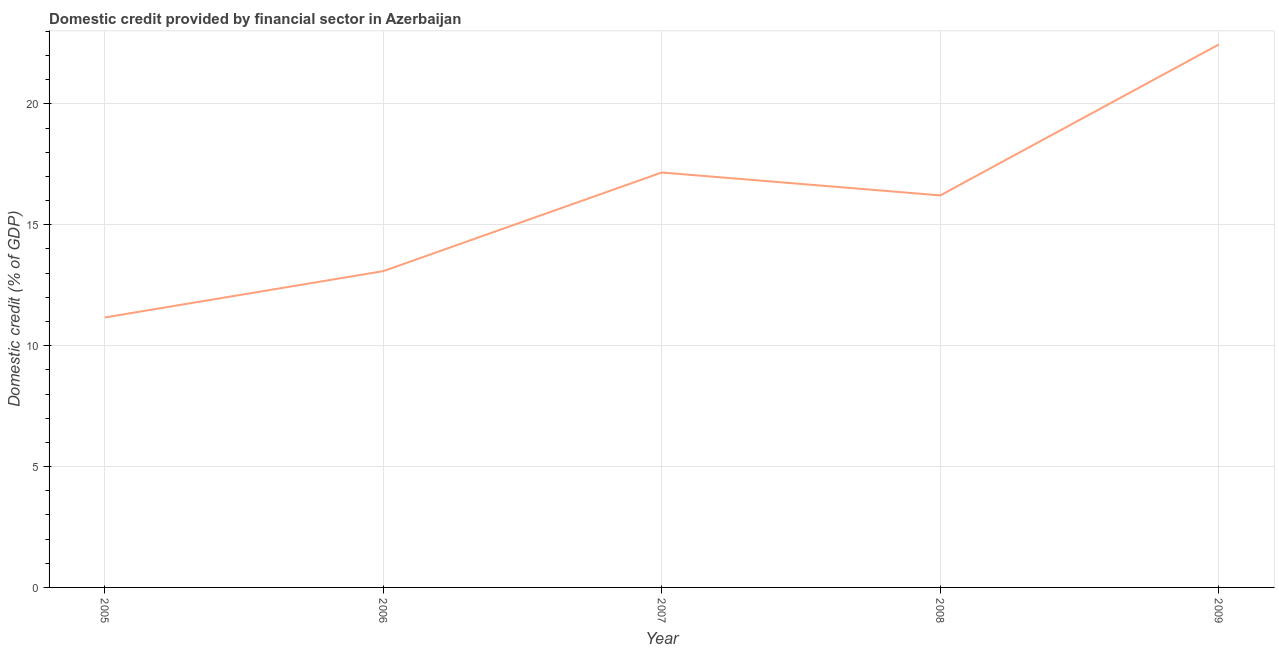What is the domestic credit provided by financial sector in 2007?
Provide a succinct answer. 17.16. Across all years, what is the maximum domestic credit provided by financial sector?
Offer a terse response. 22.46. Across all years, what is the minimum domestic credit provided by financial sector?
Ensure brevity in your answer.  11.17. In which year was the domestic credit provided by financial sector maximum?
Make the answer very short. 2009. In which year was the domestic credit provided by financial sector minimum?
Give a very brief answer. 2005. What is the sum of the domestic credit provided by financial sector?
Offer a very short reply. 80.08. What is the difference between the domestic credit provided by financial sector in 2005 and 2008?
Keep it short and to the point. -5.05. What is the average domestic credit provided by financial sector per year?
Your answer should be very brief. 16.02. What is the median domestic credit provided by financial sector?
Offer a very short reply. 16.22. In how many years, is the domestic credit provided by financial sector greater than 21 %?
Give a very brief answer. 1. Do a majority of the years between 2009 and 2008 (inclusive) have domestic credit provided by financial sector greater than 4 %?
Give a very brief answer. No. What is the ratio of the domestic credit provided by financial sector in 2006 to that in 2008?
Provide a succinct answer. 0.81. Is the domestic credit provided by financial sector in 2005 less than that in 2006?
Offer a terse response. Yes. Is the difference between the domestic credit provided by financial sector in 2005 and 2008 greater than the difference between any two years?
Provide a succinct answer. No. What is the difference between the highest and the second highest domestic credit provided by financial sector?
Ensure brevity in your answer.  5.3. What is the difference between the highest and the lowest domestic credit provided by financial sector?
Make the answer very short. 11.29. In how many years, is the domestic credit provided by financial sector greater than the average domestic credit provided by financial sector taken over all years?
Keep it short and to the point. 3. How many lines are there?
Your response must be concise. 1. Does the graph contain any zero values?
Make the answer very short. No. Does the graph contain grids?
Ensure brevity in your answer.  Yes. What is the title of the graph?
Offer a very short reply. Domestic credit provided by financial sector in Azerbaijan. What is the label or title of the X-axis?
Your answer should be compact. Year. What is the label or title of the Y-axis?
Ensure brevity in your answer.  Domestic credit (% of GDP). What is the Domestic credit (% of GDP) of 2005?
Provide a succinct answer. 11.17. What is the Domestic credit (% of GDP) in 2006?
Offer a very short reply. 13.08. What is the Domestic credit (% of GDP) of 2007?
Offer a very short reply. 17.16. What is the Domestic credit (% of GDP) of 2008?
Provide a short and direct response. 16.22. What is the Domestic credit (% of GDP) of 2009?
Give a very brief answer. 22.46. What is the difference between the Domestic credit (% of GDP) in 2005 and 2006?
Ensure brevity in your answer.  -1.92. What is the difference between the Domestic credit (% of GDP) in 2005 and 2007?
Ensure brevity in your answer.  -6. What is the difference between the Domestic credit (% of GDP) in 2005 and 2008?
Your response must be concise. -5.05. What is the difference between the Domestic credit (% of GDP) in 2005 and 2009?
Offer a terse response. -11.29. What is the difference between the Domestic credit (% of GDP) in 2006 and 2007?
Make the answer very short. -4.08. What is the difference between the Domestic credit (% of GDP) in 2006 and 2008?
Offer a very short reply. -3.13. What is the difference between the Domestic credit (% of GDP) in 2006 and 2009?
Your answer should be compact. -9.37. What is the difference between the Domestic credit (% of GDP) in 2007 and 2008?
Offer a very short reply. 0.95. What is the difference between the Domestic credit (% of GDP) in 2007 and 2009?
Keep it short and to the point. -5.3. What is the difference between the Domestic credit (% of GDP) in 2008 and 2009?
Keep it short and to the point. -6.24. What is the ratio of the Domestic credit (% of GDP) in 2005 to that in 2006?
Your response must be concise. 0.85. What is the ratio of the Domestic credit (% of GDP) in 2005 to that in 2007?
Offer a terse response. 0.65. What is the ratio of the Domestic credit (% of GDP) in 2005 to that in 2008?
Your answer should be compact. 0.69. What is the ratio of the Domestic credit (% of GDP) in 2005 to that in 2009?
Keep it short and to the point. 0.5. What is the ratio of the Domestic credit (% of GDP) in 2006 to that in 2007?
Your response must be concise. 0.76. What is the ratio of the Domestic credit (% of GDP) in 2006 to that in 2008?
Offer a very short reply. 0.81. What is the ratio of the Domestic credit (% of GDP) in 2006 to that in 2009?
Give a very brief answer. 0.58. What is the ratio of the Domestic credit (% of GDP) in 2007 to that in 2008?
Ensure brevity in your answer.  1.06. What is the ratio of the Domestic credit (% of GDP) in 2007 to that in 2009?
Offer a very short reply. 0.76. What is the ratio of the Domestic credit (% of GDP) in 2008 to that in 2009?
Your response must be concise. 0.72. 